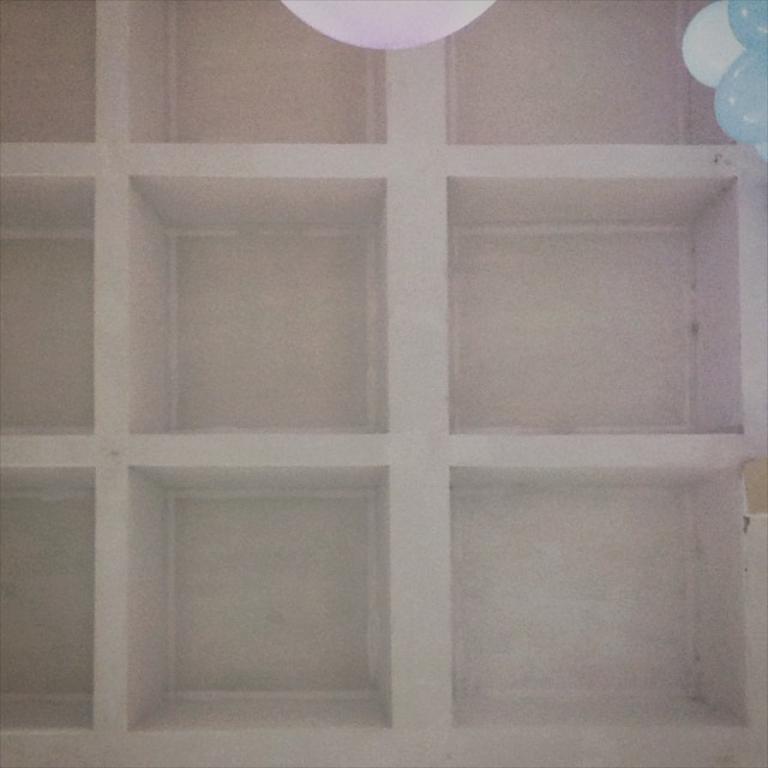Could you give a brief overview of what you see in this image? In this image there are empty shelves. On top of the image there are balloons. 